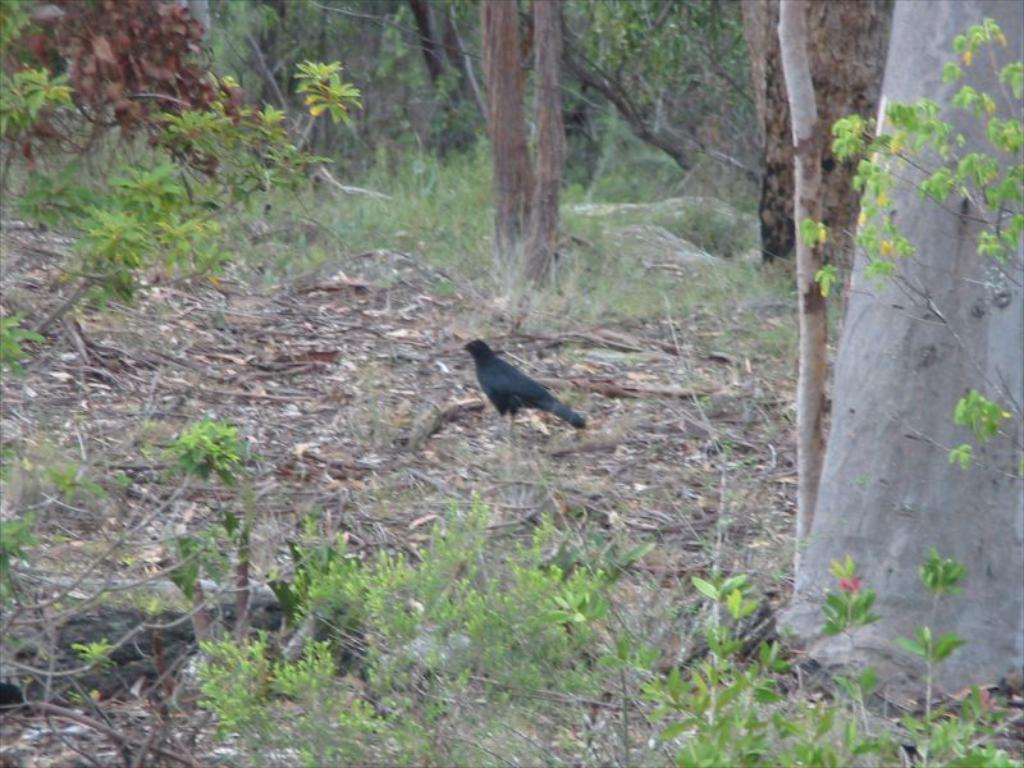What type of animal is on the ground in the image? There is a bird on the ground in the image. What type of vegetation is present in the image? There are plants, grass, and trees in the image. What disease is the bird suffering from in the image? There is no indication in the image that the bird is suffering from any disease. 